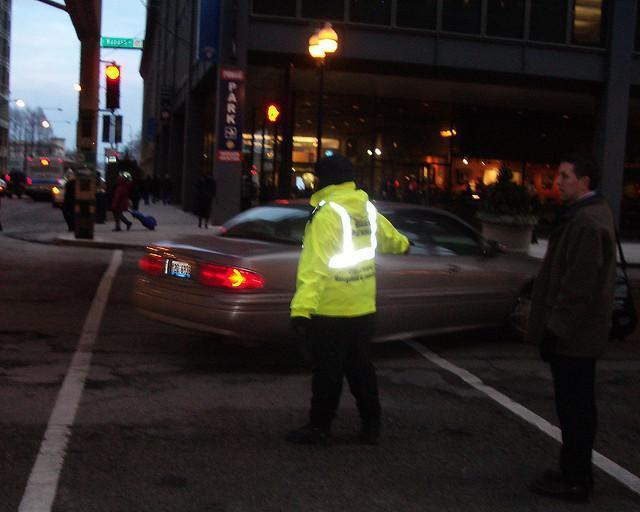How many people are there?
Give a very brief answer. 2. How many bicycles are on the other side of the street?
Give a very brief answer. 0. 